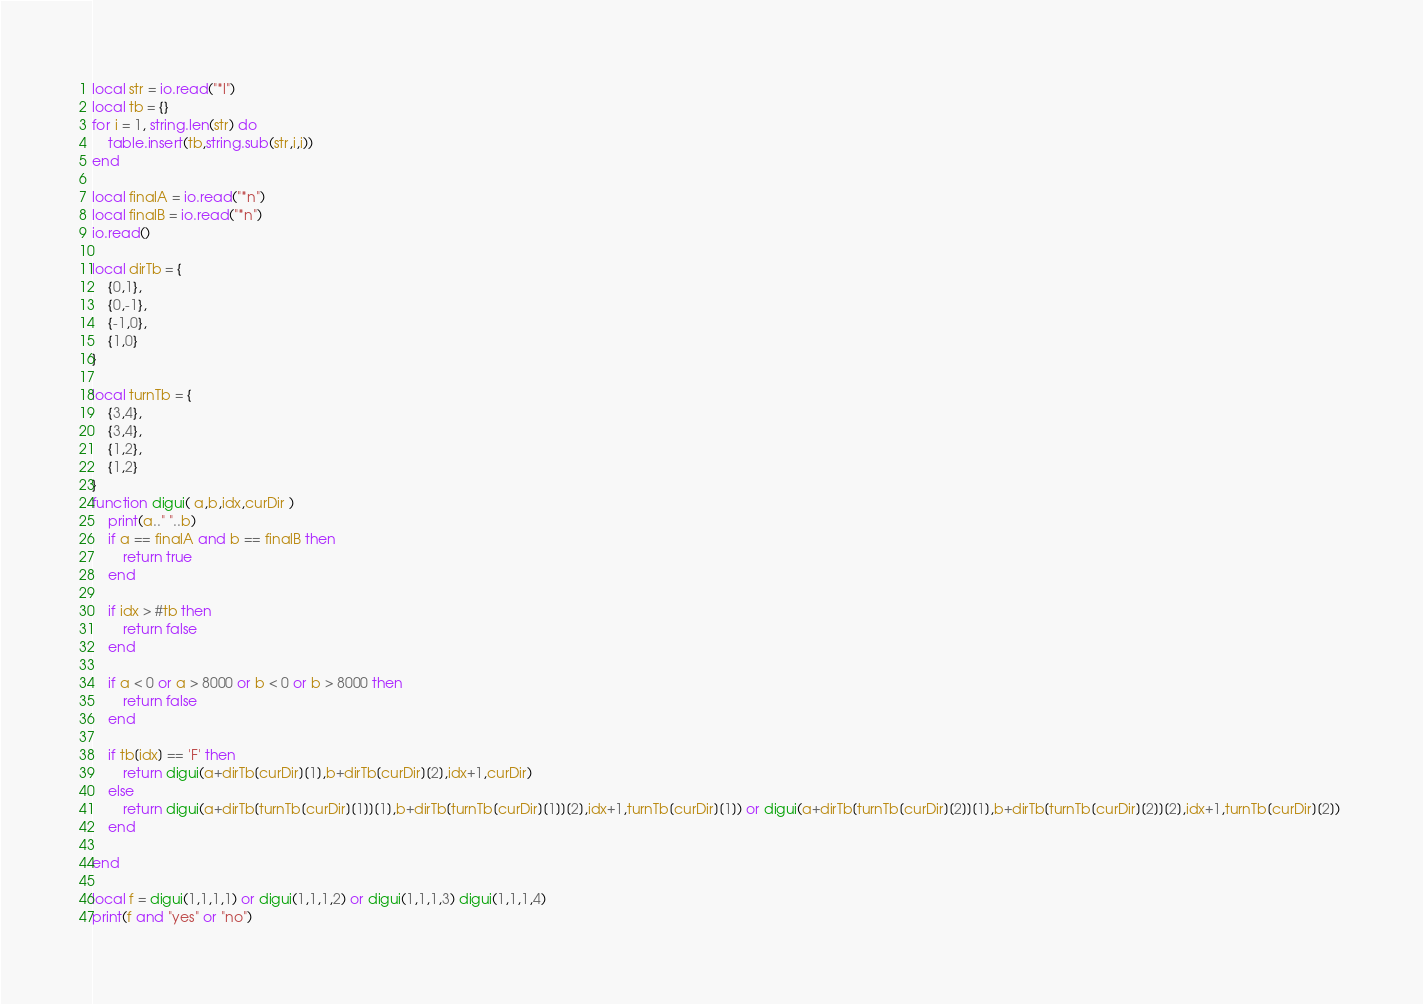<code> <loc_0><loc_0><loc_500><loc_500><_Lua_>local str = io.read("*l")
local tb = {}
for i = 1, string.len(str) do
    table.insert(tb,string.sub(str,i,i))
end

local finalA = io.read("*n")
local finalB = io.read("*n")
io.read()

local dirTb = {
    {0,1},
    {0,-1},
    {-1,0},
    {1,0}
}

local turnTb = {
    {3,4},
    {3,4},
    {1,2},
    {1,2}
}
function digui( a,b,idx,curDir )
    print(a.." "..b)
    if a == finalA and b == finalB then
        return true
    end

    if idx > #tb then
        return false
    end

    if a < 0 or a > 8000 or b < 0 or b > 8000 then
        return false
    end

    if tb[idx] == 'F' then
        return digui(a+dirTb[curDir][1],b+dirTb[curDir][2],idx+1,curDir)
    else
        return digui(a+dirTb[turnTb[curDir][1]][1],b+dirTb[turnTb[curDir][1]][2],idx+1,turnTb[curDir][1]) or digui(a+dirTb[turnTb[curDir][2]][1],b+dirTb[turnTb[curDir][2]][2],idx+1,turnTb[curDir][2]) 
    end

end

local f = digui(1,1,1,1) or digui(1,1,1,2) or digui(1,1,1,3) digui(1,1,1,4)
print(f and "yes" or "no")</code> 